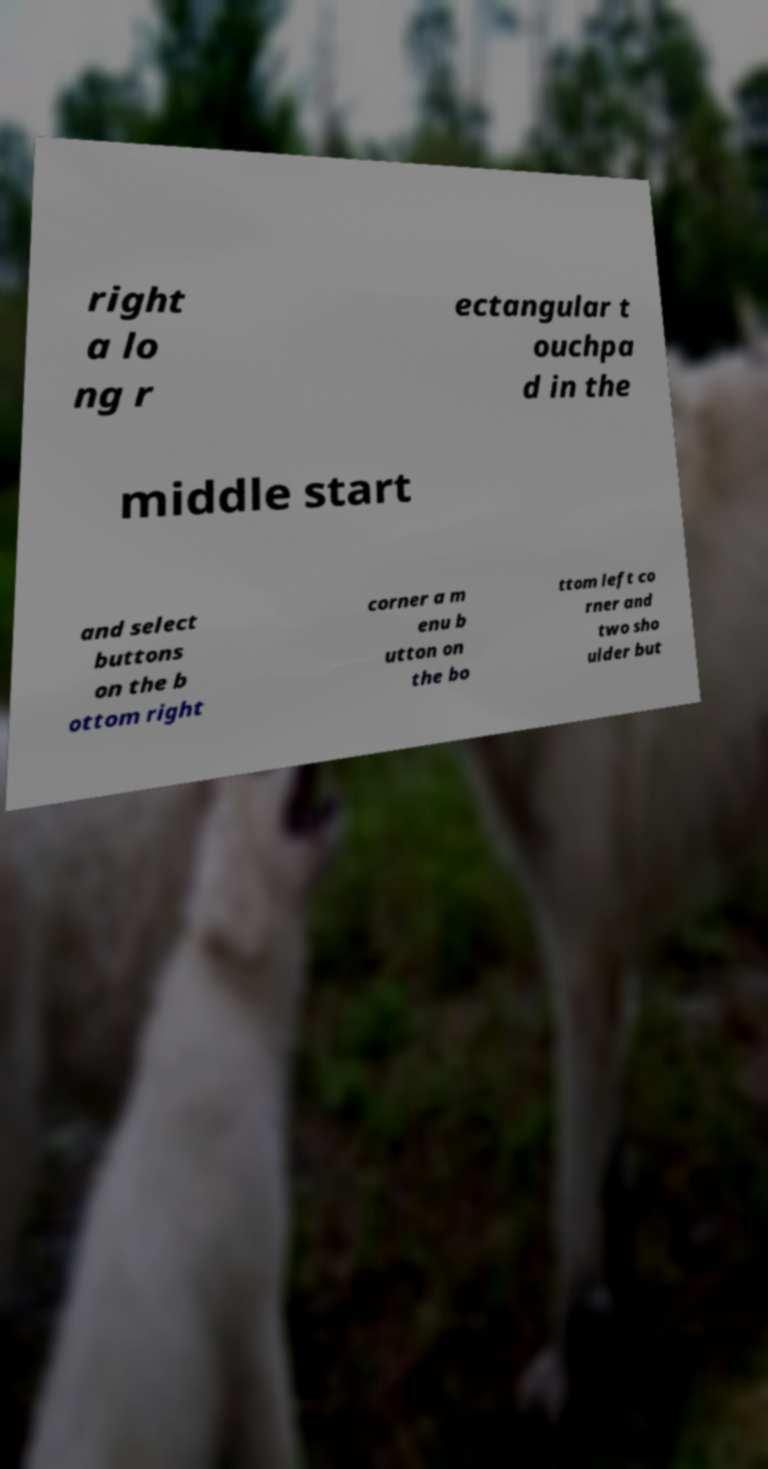Please identify and transcribe the text found in this image. right a lo ng r ectangular t ouchpa d in the middle start and select buttons on the b ottom right corner a m enu b utton on the bo ttom left co rner and two sho ulder but 